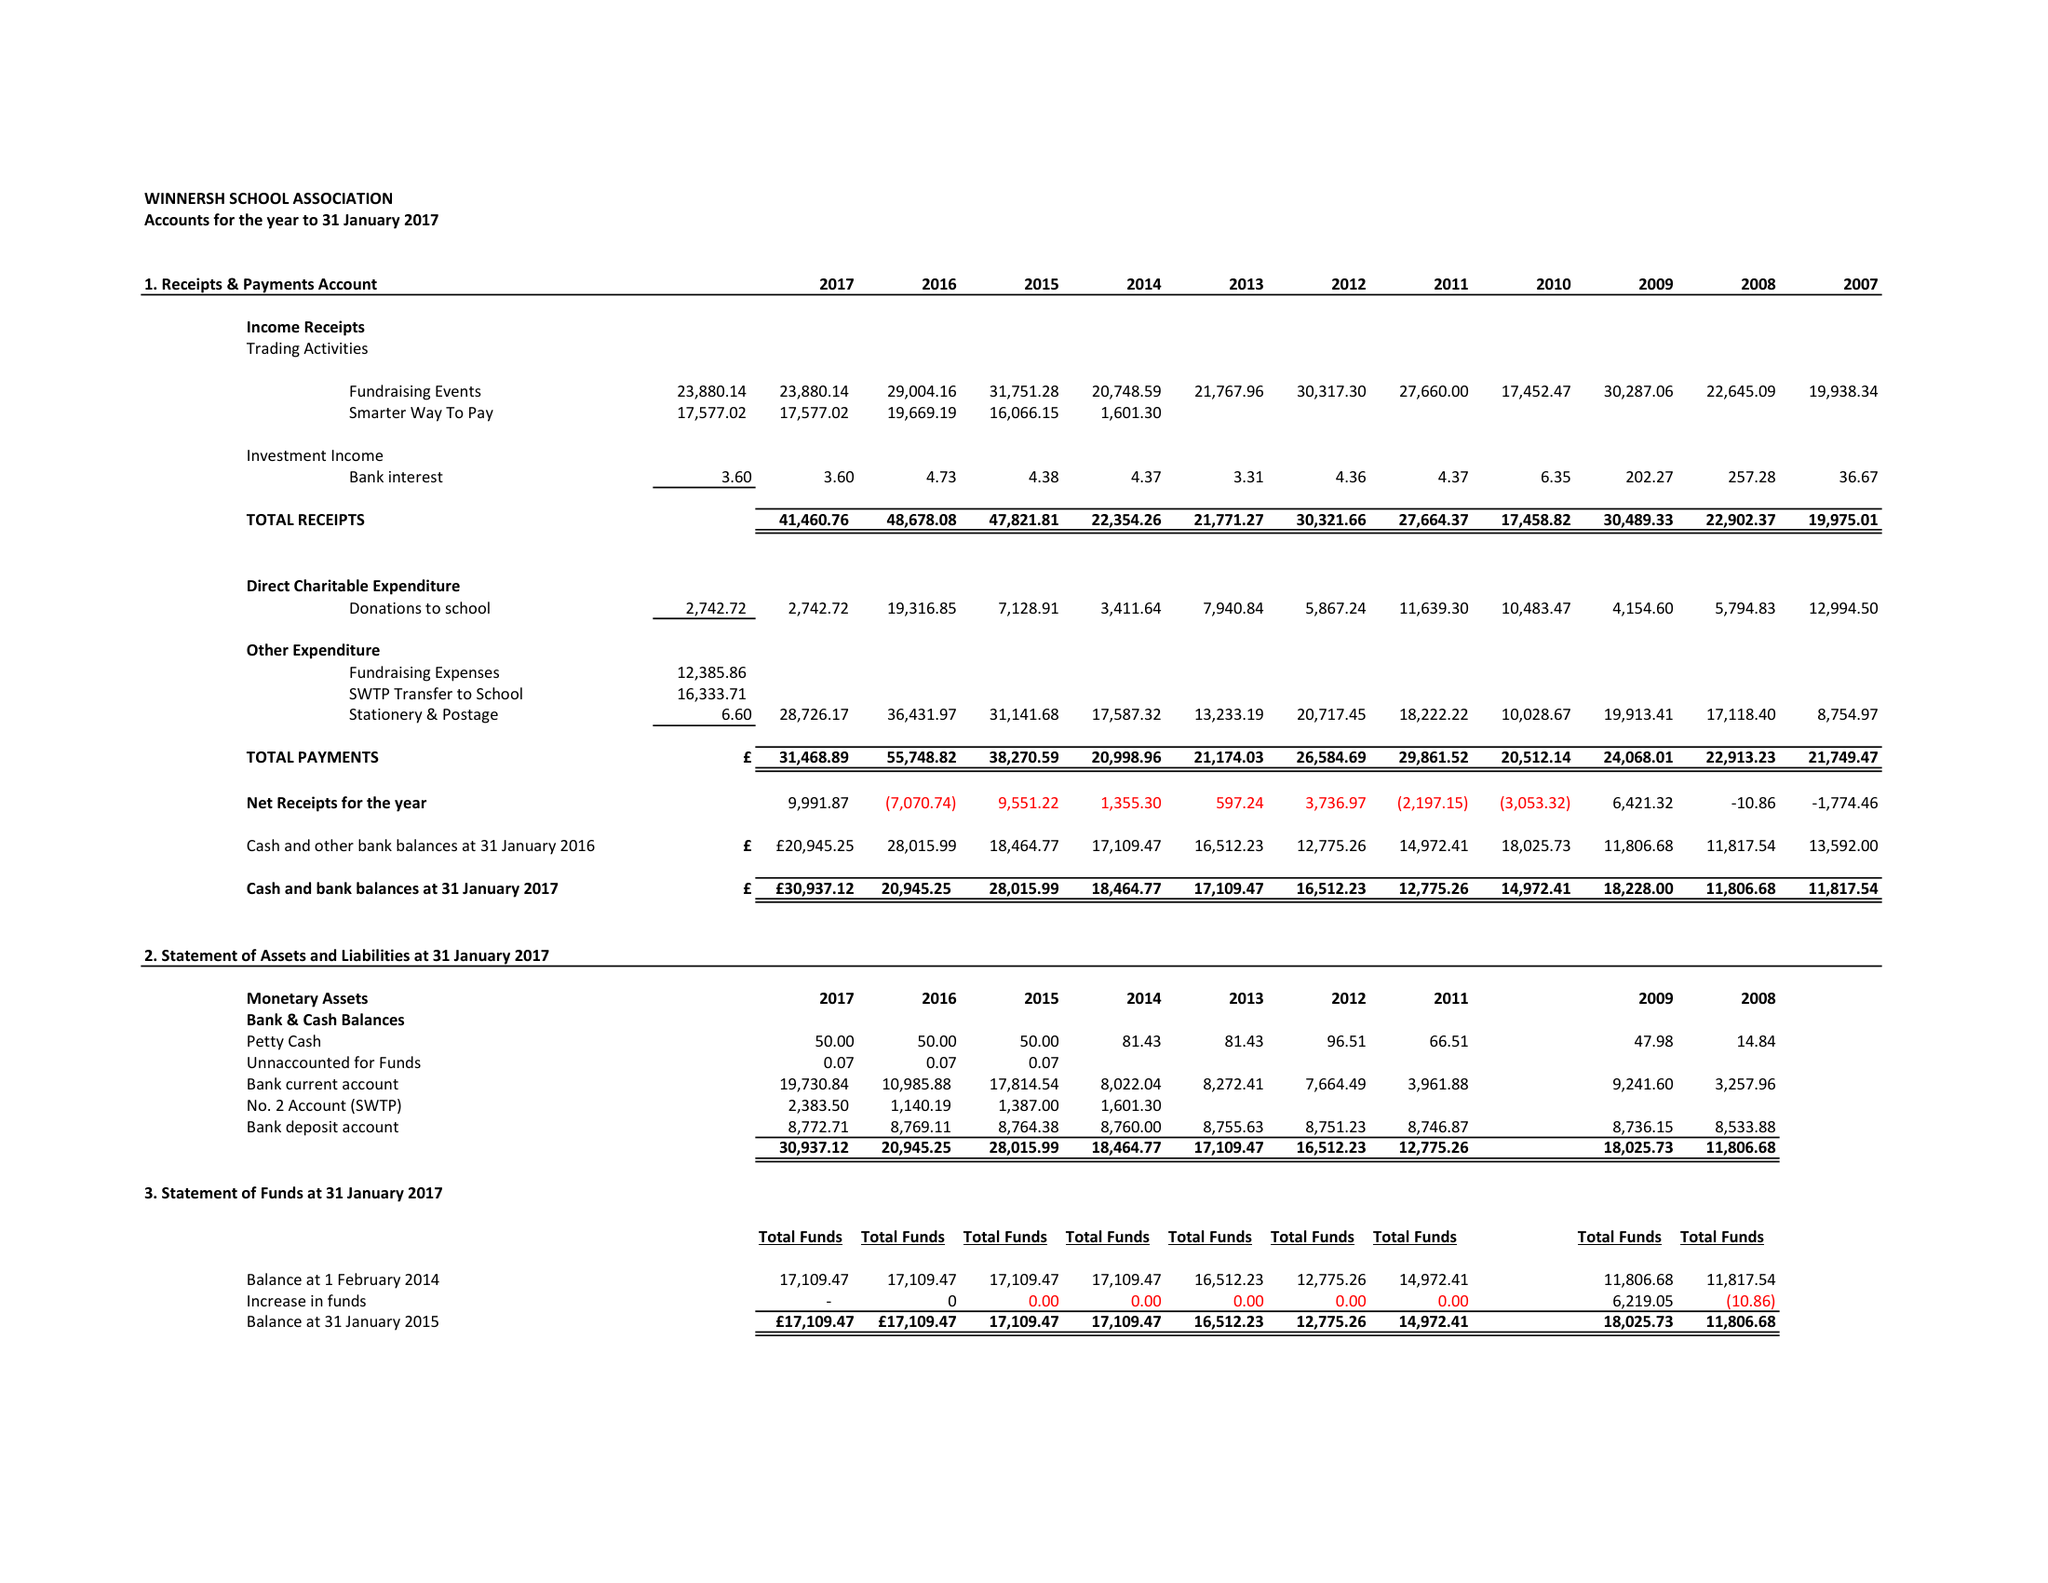What is the value for the address__street_line?
Answer the question using a single word or phrase. 20 GREENWOOD GROVE 